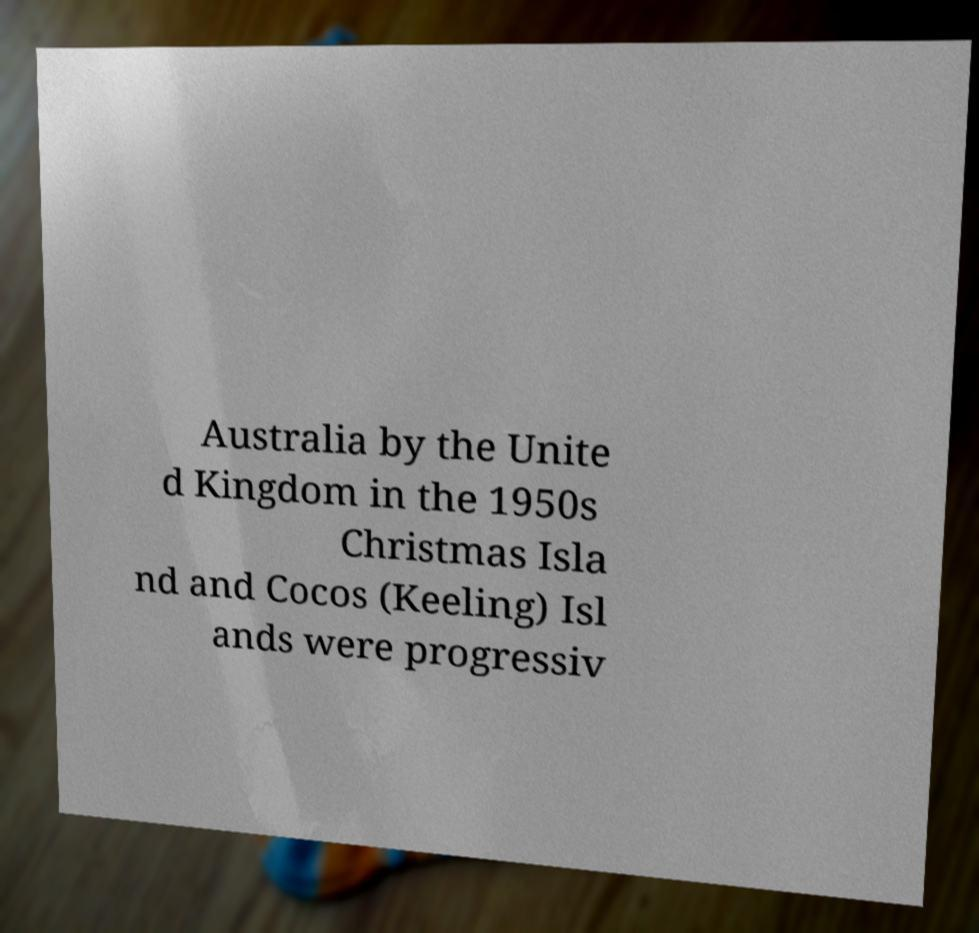Can you read and provide the text displayed in the image?This photo seems to have some interesting text. Can you extract and type it out for me? Australia by the Unite d Kingdom in the 1950s Christmas Isla nd and Cocos (Keeling) Isl ands were progressiv 